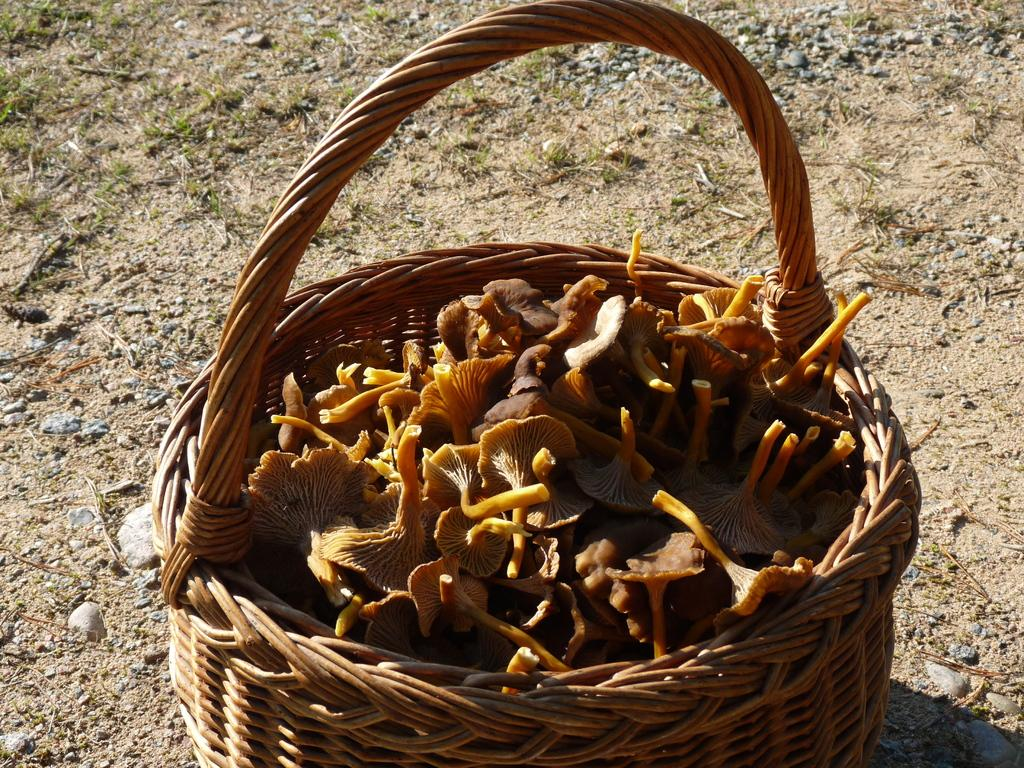What is contained within the basket in the image? There are flowers in a basket in the image. What type of vegetation can be seen on the ground in the image? There is grass visible on the ground in the image. What type of substance is being emitted by the flowers in the image? The flowers in the image are not emitting any substance; they are simply contained within the basket. 